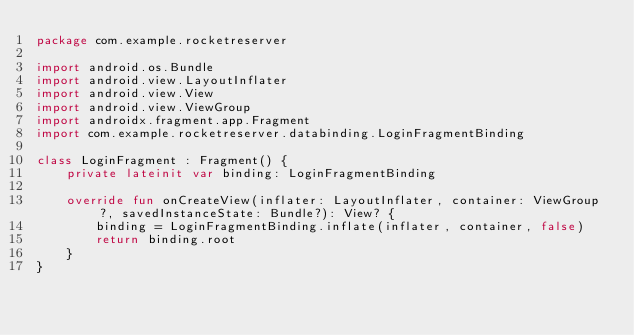Convert code to text. <code><loc_0><loc_0><loc_500><loc_500><_Kotlin_>package com.example.rocketreserver

import android.os.Bundle
import android.view.LayoutInflater
import android.view.View
import android.view.ViewGroup
import androidx.fragment.app.Fragment
import com.example.rocketreserver.databinding.LoginFragmentBinding

class LoginFragment : Fragment() {
    private lateinit var binding: LoginFragmentBinding

    override fun onCreateView(inflater: LayoutInflater, container: ViewGroup?, savedInstanceState: Bundle?): View? {
        binding = LoginFragmentBinding.inflate(inflater, container, false)
        return binding.root
    }
}</code> 